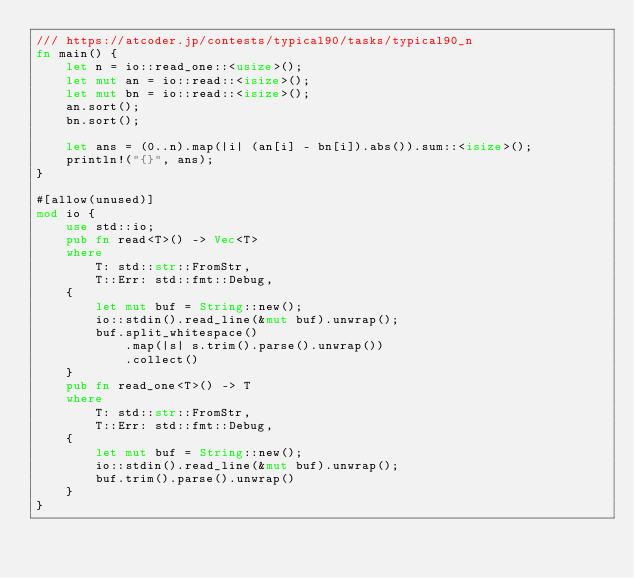Convert code to text. <code><loc_0><loc_0><loc_500><loc_500><_Rust_>/// https://atcoder.jp/contests/typical90/tasks/typical90_n
fn main() {
    let n = io::read_one::<usize>();
    let mut an = io::read::<isize>();
    let mut bn = io::read::<isize>();
    an.sort();
    bn.sort();

    let ans = (0..n).map(|i| (an[i] - bn[i]).abs()).sum::<isize>();
    println!("{}", ans);
}

#[allow(unused)]
mod io {
    use std::io;
    pub fn read<T>() -> Vec<T>
    where
        T: std::str::FromStr,
        T::Err: std::fmt::Debug,
    {
        let mut buf = String::new();
        io::stdin().read_line(&mut buf).unwrap();
        buf.split_whitespace()
            .map(|s| s.trim().parse().unwrap())
            .collect()
    }
    pub fn read_one<T>() -> T
    where
        T: std::str::FromStr,
        T::Err: std::fmt::Debug,
    {
        let mut buf = String::new();
        io::stdin().read_line(&mut buf).unwrap();
        buf.trim().parse().unwrap()
    }
}
</code> 